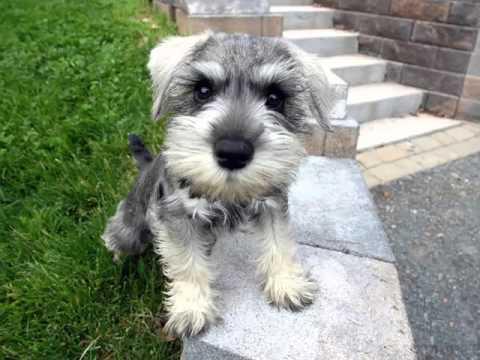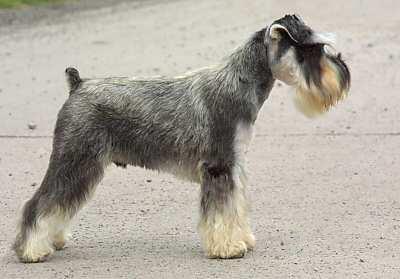The first image is the image on the left, the second image is the image on the right. Considering the images on both sides, is "The dog in the image on the right is shown as a side profile." valid? Answer yes or no. Yes. 